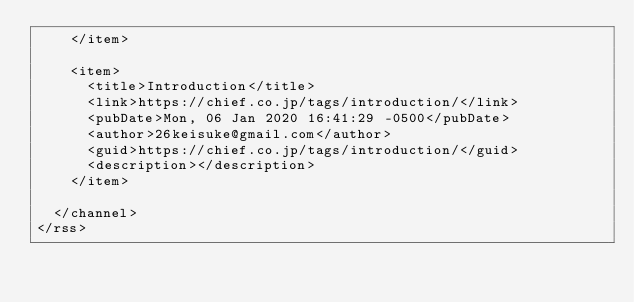Convert code to text. <code><loc_0><loc_0><loc_500><loc_500><_XML_>    </item>
    
    <item>
      <title>Introduction</title>
      <link>https://chief.co.jp/tags/introduction/</link>
      <pubDate>Mon, 06 Jan 2020 16:41:29 -0500</pubDate>
      <author>26keisuke@gmail.com</author>
      <guid>https://chief.co.jp/tags/introduction/</guid>
      <description></description>
    </item>
    
  </channel>
</rss></code> 